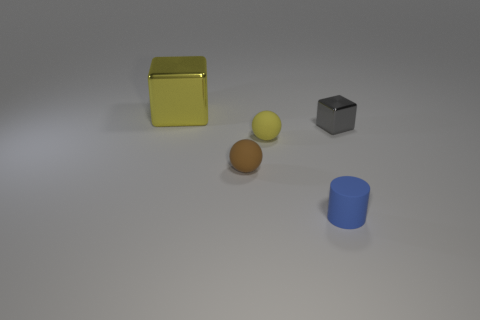There is another small object that is the same shape as the small yellow matte object; what is its color?
Your answer should be very brief. Brown. The cylinder that is to the right of the cube to the left of the tiny yellow ball is what color?
Give a very brief answer. Blue. What is the shape of the big yellow metal object?
Ensure brevity in your answer.  Cube. What shape is the object that is on the left side of the tiny cylinder and right of the small brown matte thing?
Provide a short and direct response. Sphere. The large thing that is made of the same material as the tiny gray thing is what color?
Offer a very short reply. Yellow. There is a matte object that is left of the yellow object in front of the metal thing that is on the left side of the small blue rubber cylinder; what is its shape?
Ensure brevity in your answer.  Sphere. The yellow shiny object is what size?
Give a very brief answer. Large. There is a blue thing that is the same material as the tiny yellow ball; what is its shape?
Provide a succinct answer. Cylinder. Is the number of metal objects in front of the yellow sphere less than the number of yellow rubber things?
Offer a very short reply. Yes. There is a block that is left of the small blue matte cylinder; what is its color?
Give a very brief answer. Yellow. 